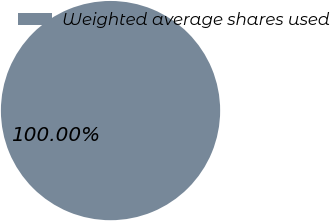Convert chart. <chart><loc_0><loc_0><loc_500><loc_500><pie_chart><fcel>Weighted average shares used<nl><fcel>100.0%<nl></chart> 